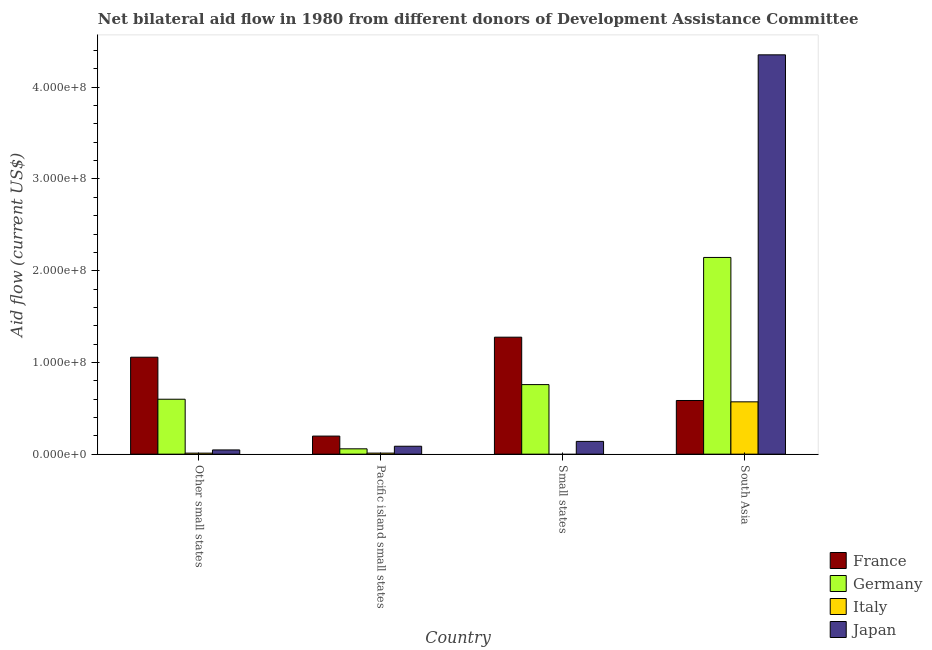Are the number of bars on each tick of the X-axis equal?
Your answer should be compact. No. How many bars are there on the 1st tick from the left?
Offer a terse response. 4. How many bars are there on the 3rd tick from the right?
Make the answer very short. 4. What is the label of the 3rd group of bars from the left?
Provide a short and direct response. Small states. What is the amount of aid given by italy in Pacific island small states?
Ensure brevity in your answer.  1.15e+06. Across all countries, what is the maximum amount of aid given by italy?
Your answer should be very brief. 5.70e+07. Across all countries, what is the minimum amount of aid given by japan?
Provide a succinct answer. 4.61e+06. In which country was the amount of aid given by japan maximum?
Make the answer very short. South Asia. What is the total amount of aid given by japan in the graph?
Offer a very short reply. 4.63e+08. What is the difference between the amount of aid given by japan in Other small states and that in Pacific island small states?
Give a very brief answer. -4.03e+06. What is the difference between the amount of aid given by italy in Pacific island small states and the amount of aid given by france in Other small states?
Ensure brevity in your answer.  -1.05e+08. What is the average amount of aid given by france per country?
Give a very brief answer. 7.79e+07. What is the difference between the amount of aid given by italy and amount of aid given by germany in South Asia?
Your response must be concise. -1.57e+08. What is the ratio of the amount of aid given by france in Pacific island small states to that in Small states?
Your answer should be compact. 0.15. Is the amount of aid given by france in Other small states less than that in South Asia?
Make the answer very short. No. Is the difference between the amount of aid given by italy in Other small states and South Asia greater than the difference between the amount of aid given by japan in Other small states and South Asia?
Provide a short and direct response. Yes. What is the difference between the highest and the second highest amount of aid given by germany?
Provide a short and direct response. 1.39e+08. What is the difference between the highest and the lowest amount of aid given by germany?
Offer a terse response. 2.09e+08. In how many countries, is the amount of aid given by japan greater than the average amount of aid given by japan taken over all countries?
Your response must be concise. 1. Is the sum of the amount of aid given by france in Other small states and Small states greater than the maximum amount of aid given by japan across all countries?
Give a very brief answer. No. Is it the case that in every country, the sum of the amount of aid given by france and amount of aid given by germany is greater than the amount of aid given by italy?
Make the answer very short. Yes. How many bars are there?
Your answer should be very brief. 15. What is the difference between two consecutive major ticks on the Y-axis?
Provide a short and direct response. 1.00e+08. Does the graph contain grids?
Ensure brevity in your answer.  No. What is the title of the graph?
Your answer should be very brief. Net bilateral aid flow in 1980 from different donors of Development Assistance Committee. What is the label or title of the X-axis?
Provide a short and direct response. Country. What is the label or title of the Y-axis?
Make the answer very short. Aid flow (current US$). What is the Aid flow (current US$) of France in Other small states?
Your answer should be compact. 1.06e+08. What is the Aid flow (current US$) of Germany in Other small states?
Provide a succinct answer. 5.99e+07. What is the Aid flow (current US$) of Italy in Other small states?
Provide a succinct answer. 1.12e+06. What is the Aid flow (current US$) of Japan in Other small states?
Offer a terse response. 4.61e+06. What is the Aid flow (current US$) of France in Pacific island small states?
Your answer should be compact. 1.97e+07. What is the Aid flow (current US$) of Germany in Pacific island small states?
Provide a succinct answer. 5.83e+06. What is the Aid flow (current US$) of Italy in Pacific island small states?
Keep it short and to the point. 1.15e+06. What is the Aid flow (current US$) in Japan in Pacific island small states?
Provide a succinct answer. 8.64e+06. What is the Aid flow (current US$) of France in Small states?
Give a very brief answer. 1.28e+08. What is the Aid flow (current US$) of Germany in Small states?
Offer a very short reply. 7.58e+07. What is the Aid flow (current US$) in Japan in Small states?
Ensure brevity in your answer.  1.39e+07. What is the Aid flow (current US$) of France in South Asia?
Keep it short and to the point. 5.85e+07. What is the Aid flow (current US$) in Germany in South Asia?
Your answer should be compact. 2.14e+08. What is the Aid flow (current US$) in Italy in South Asia?
Offer a very short reply. 5.70e+07. What is the Aid flow (current US$) of Japan in South Asia?
Your answer should be very brief. 4.35e+08. Across all countries, what is the maximum Aid flow (current US$) in France?
Your response must be concise. 1.28e+08. Across all countries, what is the maximum Aid flow (current US$) in Germany?
Offer a terse response. 2.14e+08. Across all countries, what is the maximum Aid flow (current US$) of Italy?
Your response must be concise. 5.70e+07. Across all countries, what is the maximum Aid flow (current US$) in Japan?
Make the answer very short. 4.35e+08. Across all countries, what is the minimum Aid flow (current US$) in France?
Ensure brevity in your answer.  1.97e+07. Across all countries, what is the minimum Aid flow (current US$) of Germany?
Make the answer very short. 5.83e+06. Across all countries, what is the minimum Aid flow (current US$) in Japan?
Your answer should be compact. 4.61e+06. What is the total Aid flow (current US$) in France in the graph?
Offer a terse response. 3.11e+08. What is the total Aid flow (current US$) of Germany in the graph?
Give a very brief answer. 3.56e+08. What is the total Aid flow (current US$) of Italy in the graph?
Give a very brief answer. 5.93e+07. What is the total Aid flow (current US$) in Japan in the graph?
Your answer should be compact. 4.63e+08. What is the difference between the Aid flow (current US$) in France in Other small states and that in Pacific island small states?
Ensure brevity in your answer.  8.60e+07. What is the difference between the Aid flow (current US$) of Germany in Other small states and that in Pacific island small states?
Keep it short and to the point. 5.41e+07. What is the difference between the Aid flow (current US$) in Italy in Other small states and that in Pacific island small states?
Provide a short and direct response. -3.00e+04. What is the difference between the Aid flow (current US$) of Japan in Other small states and that in Pacific island small states?
Offer a terse response. -4.03e+06. What is the difference between the Aid flow (current US$) in France in Other small states and that in Small states?
Your answer should be very brief. -2.18e+07. What is the difference between the Aid flow (current US$) of Germany in Other small states and that in Small states?
Make the answer very short. -1.59e+07. What is the difference between the Aid flow (current US$) of Japan in Other small states and that in Small states?
Provide a short and direct response. -9.31e+06. What is the difference between the Aid flow (current US$) in France in Other small states and that in South Asia?
Provide a succinct answer. 4.72e+07. What is the difference between the Aid flow (current US$) of Germany in Other small states and that in South Asia?
Provide a short and direct response. -1.55e+08. What is the difference between the Aid flow (current US$) in Italy in Other small states and that in South Asia?
Provide a succinct answer. -5.59e+07. What is the difference between the Aid flow (current US$) in Japan in Other small states and that in South Asia?
Your answer should be compact. -4.31e+08. What is the difference between the Aid flow (current US$) of France in Pacific island small states and that in Small states?
Your answer should be very brief. -1.08e+08. What is the difference between the Aid flow (current US$) of Germany in Pacific island small states and that in Small states?
Provide a succinct answer. -7.00e+07. What is the difference between the Aid flow (current US$) of Japan in Pacific island small states and that in Small states?
Provide a succinct answer. -5.28e+06. What is the difference between the Aid flow (current US$) of France in Pacific island small states and that in South Asia?
Offer a very short reply. -3.88e+07. What is the difference between the Aid flow (current US$) of Germany in Pacific island small states and that in South Asia?
Your answer should be very brief. -2.09e+08. What is the difference between the Aid flow (current US$) of Italy in Pacific island small states and that in South Asia?
Offer a very short reply. -5.59e+07. What is the difference between the Aid flow (current US$) of Japan in Pacific island small states and that in South Asia?
Offer a very short reply. -4.27e+08. What is the difference between the Aid flow (current US$) in France in Small states and that in South Asia?
Offer a very short reply. 6.90e+07. What is the difference between the Aid flow (current US$) of Germany in Small states and that in South Asia?
Your answer should be very brief. -1.39e+08. What is the difference between the Aid flow (current US$) in Japan in Small states and that in South Asia?
Your response must be concise. -4.21e+08. What is the difference between the Aid flow (current US$) in France in Other small states and the Aid flow (current US$) in Germany in Pacific island small states?
Your response must be concise. 9.99e+07. What is the difference between the Aid flow (current US$) in France in Other small states and the Aid flow (current US$) in Italy in Pacific island small states?
Your response must be concise. 1.05e+08. What is the difference between the Aid flow (current US$) of France in Other small states and the Aid flow (current US$) of Japan in Pacific island small states?
Your answer should be very brief. 9.70e+07. What is the difference between the Aid flow (current US$) in Germany in Other small states and the Aid flow (current US$) in Italy in Pacific island small states?
Your answer should be very brief. 5.88e+07. What is the difference between the Aid flow (current US$) of Germany in Other small states and the Aid flow (current US$) of Japan in Pacific island small states?
Provide a succinct answer. 5.13e+07. What is the difference between the Aid flow (current US$) of Italy in Other small states and the Aid flow (current US$) of Japan in Pacific island small states?
Your response must be concise. -7.52e+06. What is the difference between the Aid flow (current US$) in France in Other small states and the Aid flow (current US$) in Germany in Small states?
Keep it short and to the point. 2.98e+07. What is the difference between the Aid flow (current US$) in France in Other small states and the Aid flow (current US$) in Japan in Small states?
Offer a very short reply. 9.18e+07. What is the difference between the Aid flow (current US$) of Germany in Other small states and the Aid flow (current US$) of Japan in Small states?
Your answer should be compact. 4.60e+07. What is the difference between the Aid flow (current US$) in Italy in Other small states and the Aid flow (current US$) in Japan in Small states?
Your answer should be compact. -1.28e+07. What is the difference between the Aid flow (current US$) of France in Other small states and the Aid flow (current US$) of Germany in South Asia?
Provide a succinct answer. -1.09e+08. What is the difference between the Aid flow (current US$) in France in Other small states and the Aid flow (current US$) in Italy in South Asia?
Offer a very short reply. 4.86e+07. What is the difference between the Aid flow (current US$) in France in Other small states and the Aid flow (current US$) in Japan in South Asia?
Provide a short and direct response. -3.30e+08. What is the difference between the Aid flow (current US$) of Germany in Other small states and the Aid flow (current US$) of Italy in South Asia?
Keep it short and to the point. 2.85e+06. What is the difference between the Aid flow (current US$) of Germany in Other small states and the Aid flow (current US$) of Japan in South Asia?
Offer a very short reply. -3.75e+08. What is the difference between the Aid flow (current US$) of Italy in Other small states and the Aid flow (current US$) of Japan in South Asia?
Offer a terse response. -4.34e+08. What is the difference between the Aid flow (current US$) in France in Pacific island small states and the Aid flow (current US$) in Germany in Small states?
Ensure brevity in your answer.  -5.61e+07. What is the difference between the Aid flow (current US$) in France in Pacific island small states and the Aid flow (current US$) in Japan in Small states?
Your response must be concise. 5.78e+06. What is the difference between the Aid flow (current US$) in Germany in Pacific island small states and the Aid flow (current US$) in Japan in Small states?
Ensure brevity in your answer.  -8.09e+06. What is the difference between the Aid flow (current US$) of Italy in Pacific island small states and the Aid flow (current US$) of Japan in Small states?
Ensure brevity in your answer.  -1.28e+07. What is the difference between the Aid flow (current US$) of France in Pacific island small states and the Aid flow (current US$) of Germany in South Asia?
Keep it short and to the point. -1.95e+08. What is the difference between the Aid flow (current US$) of France in Pacific island small states and the Aid flow (current US$) of Italy in South Asia?
Give a very brief answer. -3.74e+07. What is the difference between the Aid flow (current US$) in France in Pacific island small states and the Aid flow (current US$) in Japan in South Asia?
Keep it short and to the point. -4.16e+08. What is the difference between the Aid flow (current US$) in Germany in Pacific island small states and the Aid flow (current US$) in Italy in South Asia?
Your answer should be very brief. -5.12e+07. What is the difference between the Aid flow (current US$) of Germany in Pacific island small states and the Aid flow (current US$) of Japan in South Asia?
Ensure brevity in your answer.  -4.30e+08. What is the difference between the Aid flow (current US$) of Italy in Pacific island small states and the Aid flow (current US$) of Japan in South Asia?
Your response must be concise. -4.34e+08. What is the difference between the Aid flow (current US$) in France in Small states and the Aid flow (current US$) in Germany in South Asia?
Provide a short and direct response. -8.69e+07. What is the difference between the Aid flow (current US$) in France in Small states and the Aid flow (current US$) in Italy in South Asia?
Your answer should be compact. 7.05e+07. What is the difference between the Aid flow (current US$) in France in Small states and the Aid flow (current US$) in Japan in South Asia?
Provide a succinct answer. -3.08e+08. What is the difference between the Aid flow (current US$) of Germany in Small states and the Aid flow (current US$) of Italy in South Asia?
Offer a terse response. 1.88e+07. What is the difference between the Aid flow (current US$) of Germany in Small states and the Aid flow (current US$) of Japan in South Asia?
Your answer should be very brief. -3.60e+08. What is the average Aid flow (current US$) in France per country?
Give a very brief answer. 7.79e+07. What is the average Aid flow (current US$) in Germany per country?
Give a very brief answer. 8.90e+07. What is the average Aid flow (current US$) in Italy per country?
Your response must be concise. 1.48e+07. What is the average Aid flow (current US$) of Japan per country?
Your answer should be compact. 1.16e+08. What is the difference between the Aid flow (current US$) of France and Aid flow (current US$) of Germany in Other small states?
Your answer should be very brief. 4.58e+07. What is the difference between the Aid flow (current US$) in France and Aid flow (current US$) in Italy in Other small states?
Ensure brevity in your answer.  1.05e+08. What is the difference between the Aid flow (current US$) of France and Aid flow (current US$) of Japan in Other small states?
Provide a short and direct response. 1.01e+08. What is the difference between the Aid flow (current US$) of Germany and Aid flow (current US$) of Italy in Other small states?
Offer a very short reply. 5.88e+07. What is the difference between the Aid flow (current US$) of Germany and Aid flow (current US$) of Japan in Other small states?
Your answer should be very brief. 5.53e+07. What is the difference between the Aid flow (current US$) of Italy and Aid flow (current US$) of Japan in Other small states?
Make the answer very short. -3.49e+06. What is the difference between the Aid flow (current US$) of France and Aid flow (current US$) of Germany in Pacific island small states?
Keep it short and to the point. 1.39e+07. What is the difference between the Aid flow (current US$) in France and Aid flow (current US$) in Italy in Pacific island small states?
Your answer should be very brief. 1.86e+07. What is the difference between the Aid flow (current US$) of France and Aid flow (current US$) of Japan in Pacific island small states?
Ensure brevity in your answer.  1.11e+07. What is the difference between the Aid flow (current US$) in Germany and Aid flow (current US$) in Italy in Pacific island small states?
Ensure brevity in your answer.  4.68e+06. What is the difference between the Aid flow (current US$) in Germany and Aid flow (current US$) in Japan in Pacific island small states?
Offer a terse response. -2.81e+06. What is the difference between the Aid flow (current US$) in Italy and Aid flow (current US$) in Japan in Pacific island small states?
Make the answer very short. -7.49e+06. What is the difference between the Aid flow (current US$) of France and Aid flow (current US$) of Germany in Small states?
Keep it short and to the point. 5.17e+07. What is the difference between the Aid flow (current US$) of France and Aid flow (current US$) of Japan in Small states?
Provide a succinct answer. 1.14e+08. What is the difference between the Aid flow (current US$) of Germany and Aid flow (current US$) of Japan in Small states?
Provide a succinct answer. 6.19e+07. What is the difference between the Aid flow (current US$) of France and Aid flow (current US$) of Germany in South Asia?
Ensure brevity in your answer.  -1.56e+08. What is the difference between the Aid flow (current US$) of France and Aid flow (current US$) of Italy in South Asia?
Provide a short and direct response. 1.47e+06. What is the difference between the Aid flow (current US$) of France and Aid flow (current US$) of Japan in South Asia?
Offer a very short reply. -3.77e+08. What is the difference between the Aid flow (current US$) in Germany and Aid flow (current US$) in Italy in South Asia?
Keep it short and to the point. 1.57e+08. What is the difference between the Aid flow (current US$) of Germany and Aid flow (current US$) of Japan in South Asia?
Provide a succinct answer. -2.21e+08. What is the difference between the Aid flow (current US$) in Italy and Aid flow (current US$) in Japan in South Asia?
Give a very brief answer. -3.78e+08. What is the ratio of the Aid flow (current US$) of France in Other small states to that in Pacific island small states?
Provide a succinct answer. 5.37. What is the ratio of the Aid flow (current US$) in Germany in Other small states to that in Pacific island small states?
Offer a terse response. 10.27. What is the ratio of the Aid flow (current US$) of Italy in Other small states to that in Pacific island small states?
Offer a terse response. 0.97. What is the ratio of the Aid flow (current US$) in Japan in Other small states to that in Pacific island small states?
Offer a very short reply. 0.53. What is the ratio of the Aid flow (current US$) of France in Other small states to that in Small states?
Offer a terse response. 0.83. What is the ratio of the Aid flow (current US$) in Germany in Other small states to that in Small states?
Your response must be concise. 0.79. What is the ratio of the Aid flow (current US$) in Japan in Other small states to that in Small states?
Make the answer very short. 0.33. What is the ratio of the Aid flow (current US$) of France in Other small states to that in South Asia?
Give a very brief answer. 1.81. What is the ratio of the Aid flow (current US$) in Germany in Other small states to that in South Asia?
Offer a very short reply. 0.28. What is the ratio of the Aid flow (current US$) in Italy in Other small states to that in South Asia?
Your answer should be compact. 0.02. What is the ratio of the Aid flow (current US$) of Japan in Other small states to that in South Asia?
Provide a succinct answer. 0.01. What is the ratio of the Aid flow (current US$) of France in Pacific island small states to that in Small states?
Provide a succinct answer. 0.15. What is the ratio of the Aid flow (current US$) in Germany in Pacific island small states to that in Small states?
Provide a succinct answer. 0.08. What is the ratio of the Aid flow (current US$) in Japan in Pacific island small states to that in Small states?
Make the answer very short. 0.62. What is the ratio of the Aid flow (current US$) in France in Pacific island small states to that in South Asia?
Make the answer very short. 0.34. What is the ratio of the Aid flow (current US$) of Germany in Pacific island small states to that in South Asia?
Your answer should be compact. 0.03. What is the ratio of the Aid flow (current US$) in Italy in Pacific island small states to that in South Asia?
Give a very brief answer. 0.02. What is the ratio of the Aid flow (current US$) of Japan in Pacific island small states to that in South Asia?
Give a very brief answer. 0.02. What is the ratio of the Aid flow (current US$) in France in Small states to that in South Asia?
Offer a terse response. 2.18. What is the ratio of the Aid flow (current US$) in Germany in Small states to that in South Asia?
Provide a succinct answer. 0.35. What is the ratio of the Aid flow (current US$) of Japan in Small states to that in South Asia?
Keep it short and to the point. 0.03. What is the difference between the highest and the second highest Aid flow (current US$) in France?
Ensure brevity in your answer.  2.18e+07. What is the difference between the highest and the second highest Aid flow (current US$) in Germany?
Keep it short and to the point. 1.39e+08. What is the difference between the highest and the second highest Aid flow (current US$) in Italy?
Give a very brief answer. 5.59e+07. What is the difference between the highest and the second highest Aid flow (current US$) of Japan?
Provide a succinct answer. 4.21e+08. What is the difference between the highest and the lowest Aid flow (current US$) in France?
Give a very brief answer. 1.08e+08. What is the difference between the highest and the lowest Aid flow (current US$) in Germany?
Provide a short and direct response. 2.09e+08. What is the difference between the highest and the lowest Aid flow (current US$) in Italy?
Your answer should be very brief. 5.70e+07. What is the difference between the highest and the lowest Aid flow (current US$) of Japan?
Your answer should be very brief. 4.31e+08. 